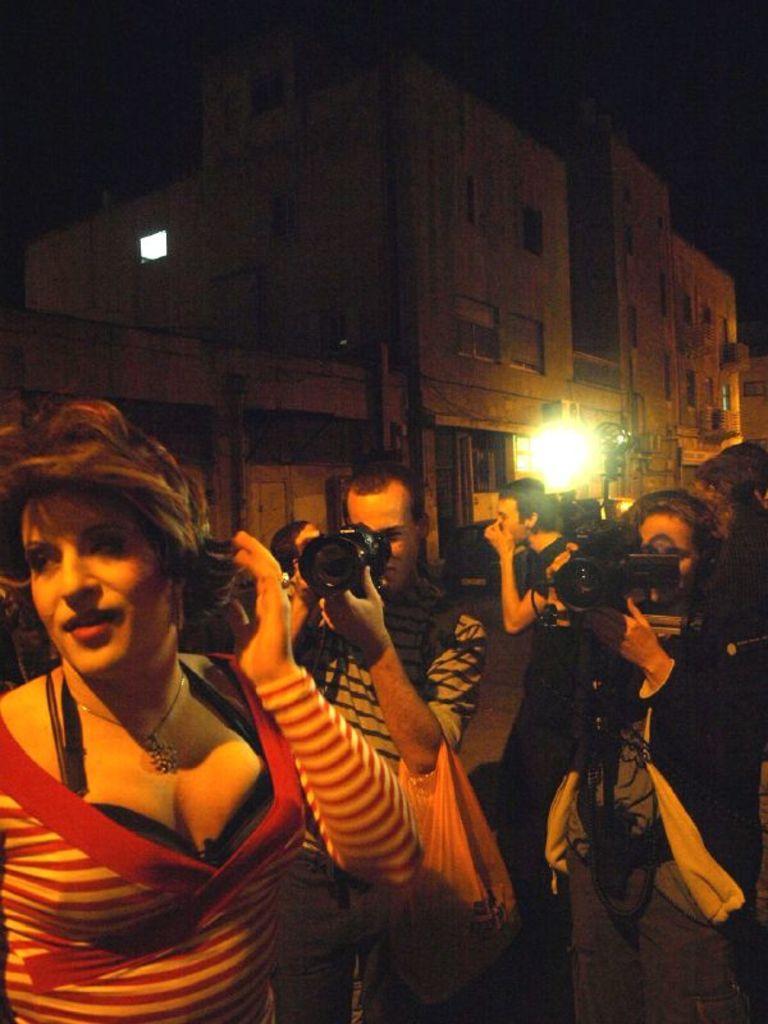Describe this image in one or two sentences. In this picture we can see a group of people standing and two people holding the cameras. Behind the people, there is a light, buildings and the dark background. 